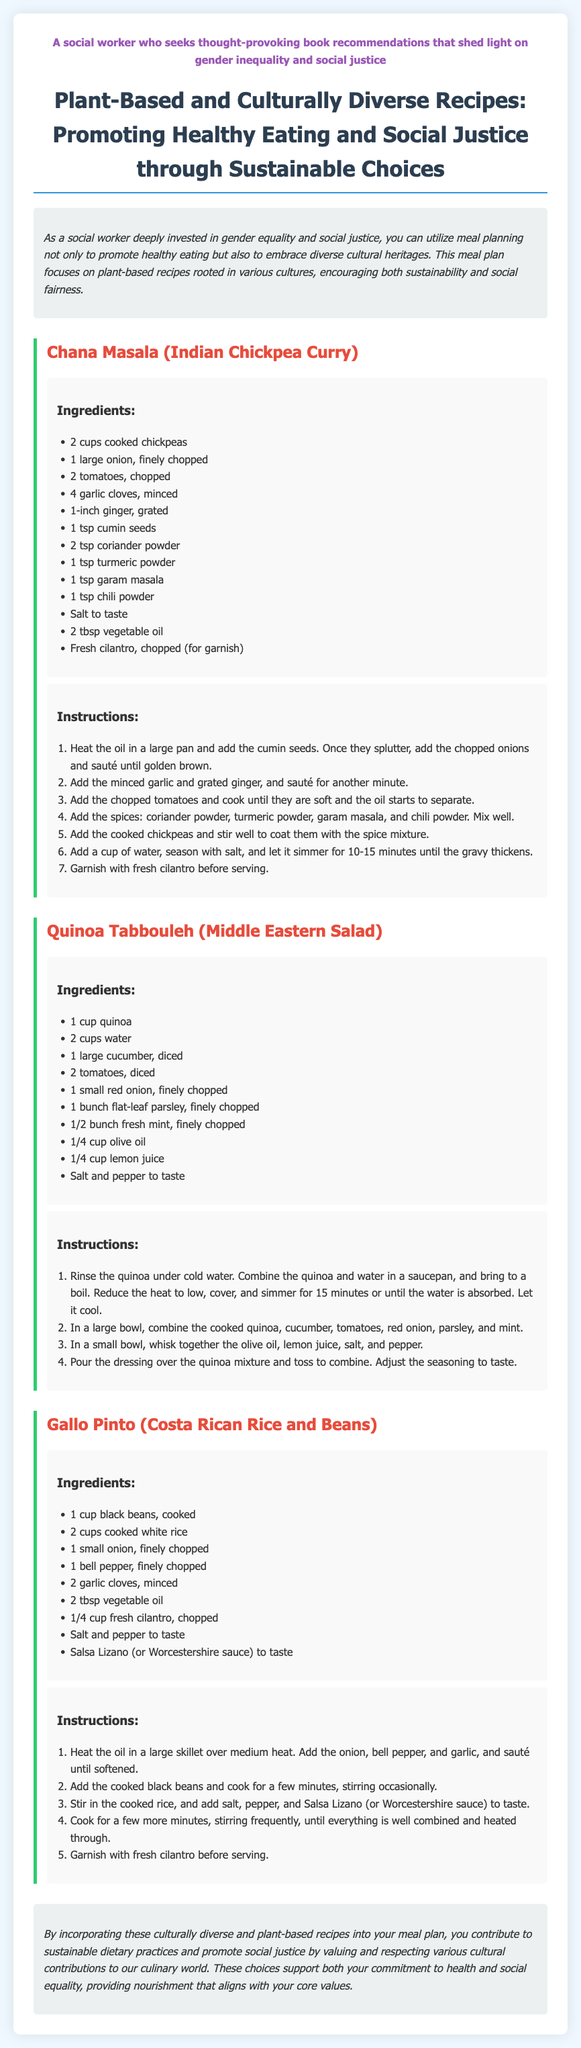What is the title of the meal plan? The title is prominently displayed at the top of the document.
Answer: Plant-Based and Culturally Diverse Recipes: Promoting Healthy Eating and Social Justice through Sustainable Choices How many recipes are included in the meal plan? The document lists three distinct recipes in the meal plan.
Answer: 3 What is the main ingredient of Chana Masala? The recipe for Chana Masala lists cooked chickpeas as the main ingredient.
Answer: Chickpeas What cultural origin is associated with Gallo Pinto? The recipe for Gallo Pinto is explicitly noted to be from Costa Rica.
Answer: Costa Rican What is a flavorful herb used in Quinoa Tabbouleh? The ingredients list mentions fresh mint as a flavorful herb.
Answer: Mint What is the cooking method for the onion in Gallo Pinto? The instructions specify that the onion is sautéed in the skillet.
Answer: Sautéed Which ingredient is used for garnishing Chana Masala? The recipe states that fresh cilantro is used as a garnish.
Answer: Cilantro What type of oil is used in the recipes? The recipes mention using vegetable oil as one of the ingredients.
Answer: Vegetable oil What is the recommended action to prepare quinoa? The instructions emphasize rinsing the quinoa before cooking.
Answer: Rinse 